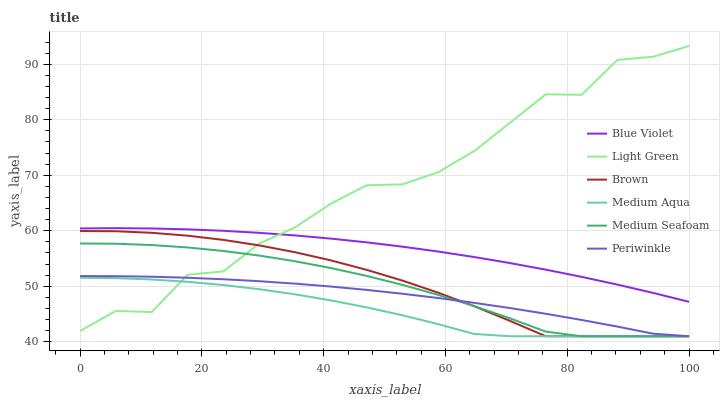Does Medium Aqua have the minimum area under the curve?
Answer yes or no. Yes. Does Light Green have the maximum area under the curve?
Answer yes or no. Yes. Does Periwinkle have the minimum area under the curve?
Answer yes or no. No. Does Periwinkle have the maximum area under the curve?
Answer yes or no. No. Is Blue Violet the smoothest?
Answer yes or no. Yes. Is Light Green the roughest?
Answer yes or no. Yes. Is Periwinkle the smoothest?
Answer yes or no. No. Is Periwinkle the roughest?
Answer yes or no. No. Does Brown have the lowest value?
Answer yes or no. Yes. Does Light Green have the lowest value?
Answer yes or no. No. Does Light Green have the highest value?
Answer yes or no. Yes. Does Periwinkle have the highest value?
Answer yes or no. No. Is Periwinkle less than Blue Violet?
Answer yes or no. Yes. Is Blue Violet greater than Brown?
Answer yes or no. Yes. Does Light Green intersect Periwinkle?
Answer yes or no. Yes. Is Light Green less than Periwinkle?
Answer yes or no. No. Is Light Green greater than Periwinkle?
Answer yes or no. No. Does Periwinkle intersect Blue Violet?
Answer yes or no. No. 